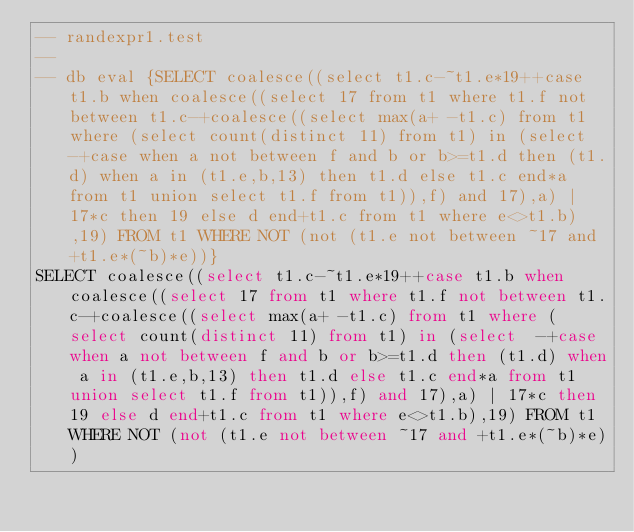Convert code to text. <code><loc_0><loc_0><loc_500><loc_500><_SQL_>-- randexpr1.test
-- 
-- db eval {SELECT coalesce((select t1.c-~t1.e*19++case t1.b when coalesce((select 17 from t1 where t1.f not between t1.c-+coalesce((select max(a+ -t1.c) from t1 where (select count(distinct 11) from t1) in (select  -+case when a not between f and b or b>=t1.d then (t1.d) when a in (t1.e,b,13) then t1.d else t1.c end*a from t1 union select t1.f from t1)),f) and 17),a) | 17*c then 19 else d end+t1.c from t1 where e<>t1.b),19) FROM t1 WHERE NOT (not (t1.e not between ~17 and +t1.e*(~b)*e))}
SELECT coalesce((select t1.c-~t1.e*19++case t1.b when coalesce((select 17 from t1 where t1.f not between t1.c-+coalesce((select max(a+ -t1.c) from t1 where (select count(distinct 11) from t1) in (select  -+case when a not between f and b or b>=t1.d then (t1.d) when a in (t1.e,b,13) then t1.d else t1.c end*a from t1 union select t1.f from t1)),f) and 17),a) | 17*c then 19 else d end+t1.c from t1 where e<>t1.b),19) FROM t1 WHERE NOT (not (t1.e not between ~17 and +t1.e*(~b)*e))</code> 